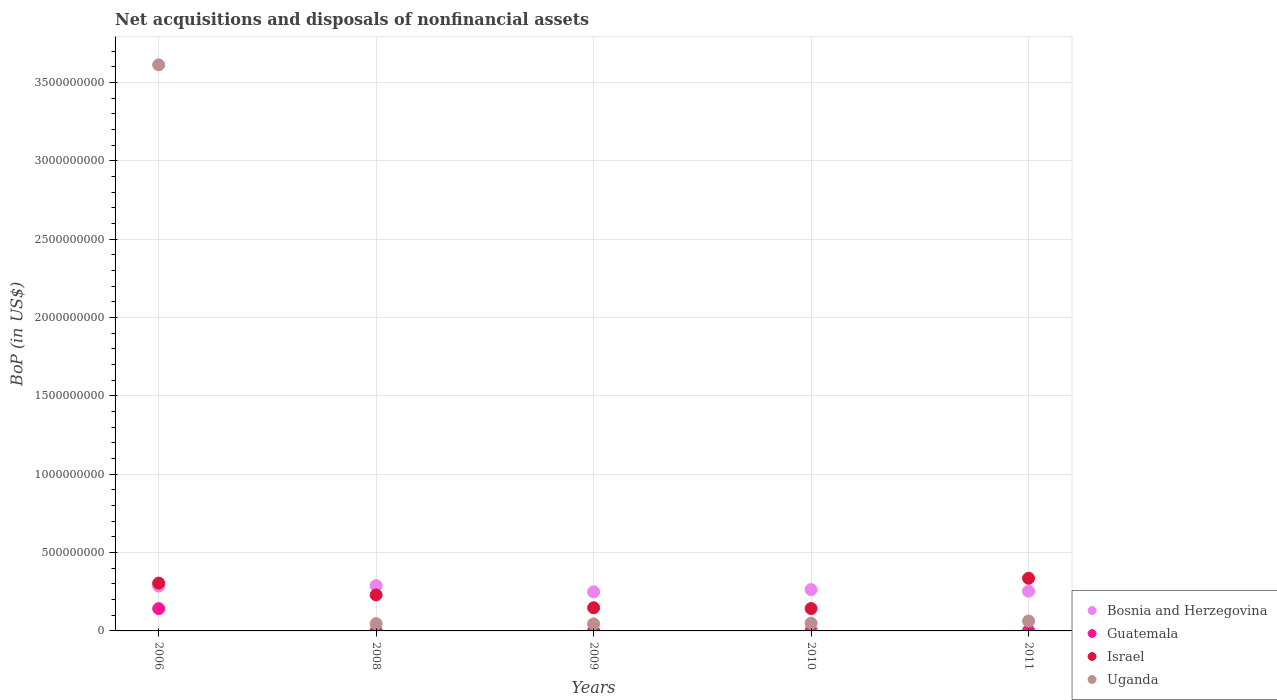How many different coloured dotlines are there?
Keep it short and to the point. 4. What is the Balance of Payments in Uganda in 2009?
Give a very brief answer. 4.49e+07. Across all years, what is the maximum Balance of Payments in Guatemala?
Keep it short and to the point. 1.42e+08. Across all years, what is the minimum Balance of Payments in Uganda?
Provide a short and direct response. 4.49e+07. In which year was the Balance of Payments in Guatemala maximum?
Your answer should be compact. 2006. In which year was the Balance of Payments in Israel minimum?
Your answer should be very brief. 2010. What is the total Balance of Payments in Bosnia and Herzegovina in the graph?
Your response must be concise. 1.34e+09. What is the difference between the Balance of Payments in Israel in 2008 and that in 2009?
Your response must be concise. 8.19e+07. What is the difference between the Balance of Payments in Uganda in 2006 and the Balance of Payments in Guatemala in 2011?
Make the answer very short. 3.61e+09. What is the average Balance of Payments in Uganda per year?
Ensure brevity in your answer.  7.63e+08. In the year 2009, what is the difference between the Balance of Payments in Bosnia and Herzegovina and Balance of Payments in Guatemala?
Your answer should be compact. 2.48e+08. In how many years, is the Balance of Payments in Guatemala greater than 3400000000 US$?
Provide a succinct answer. 0. What is the ratio of the Balance of Payments in Israel in 2006 to that in 2009?
Offer a terse response. 2.07. What is the difference between the highest and the second highest Balance of Payments in Uganda?
Offer a very short reply. 3.55e+09. What is the difference between the highest and the lowest Balance of Payments in Uganda?
Your response must be concise. 3.57e+09. Is it the case that in every year, the sum of the Balance of Payments in Bosnia and Herzegovina and Balance of Payments in Uganda  is greater than the Balance of Payments in Guatemala?
Ensure brevity in your answer.  Yes. Is the Balance of Payments in Uganda strictly greater than the Balance of Payments in Israel over the years?
Give a very brief answer. No. How many years are there in the graph?
Provide a short and direct response. 5. Does the graph contain grids?
Your answer should be compact. Yes. Where does the legend appear in the graph?
Provide a short and direct response. Bottom right. How many legend labels are there?
Provide a succinct answer. 4. How are the legend labels stacked?
Ensure brevity in your answer.  Vertical. What is the title of the graph?
Make the answer very short. Net acquisitions and disposals of nonfinancial assets. What is the label or title of the Y-axis?
Your response must be concise. BoP (in US$). What is the BoP (in US$) of Bosnia and Herzegovina in 2006?
Your answer should be compact. 2.86e+08. What is the BoP (in US$) in Guatemala in 2006?
Give a very brief answer. 1.42e+08. What is the BoP (in US$) in Israel in 2006?
Ensure brevity in your answer.  3.05e+08. What is the BoP (in US$) in Uganda in 2006?
Your response must be concise. 3.61e+09. What is the BoP (in US$) of Bosnia and Herzegovina in 2008?
Keep it short and to the point. 2.89e+08. What is the BoP (in US$) of Guatemala in 2008?
Ensure brevity in your answer.  1.08e+06. What is the BoP (in US$) of Israel in 2008?
Make the answer very short. 2.30e+08. What is the BoP (in US$) of Uganda in 2008?
Give a very brief answer. 4.65e+07. What is the BoP (in US$) of Bosnia and Herzegovina in 2009?
Provide a succinct answer. 2.49e+08. What is the BoP (in US$) of Guatemala in 2009?
Ensure brevity in your answer.  1.01e+06. What is the BoP (in US$) in Israel in 2009?
Ensure brevity in your answer.  1.48e+08. What is the BoP (in US$) in Uganda in 2009?
Provide a succinct answer. 4.49e+07. What is the BoP (in US$) in Bosnia and Herzegovina in 2010?
Make the answer very short. 2.64e+08. What is the BoP (in US$) in Guatemala in 2010?
Offer a terse response. 2.53e+06. What is the BoP (in US$) of Israel in 2010?
Your answer should be compact. 1.43e+08. What is the BoP (in US$) in Uganda in 2010?
Keep it short and to the point. 4.91e+07. What is the BoP (in US$) of Bosnia and Herzegovina in 2011?
Make the answer very short. 2.54e+08. What is the BoP (in US$) of Guatemala in 2011?
Your answer should be very brief. 2.63e+06. What is the BoP (in US$) of Israel in 2011?
Give a very brief answer. 3.36e+08. What is the BoP (in US$) in Uganda in 2011?
Provide a succinct answer. 6.34e+07. Across all years, what is the maximum BoP (in US$) of Bosnia and Herzegovina?
Offer a terse response. 2.89e+08. Across all years, what is the maximum BoP (in US$) in Guatemala?
Provide a short and direct response. 1.42e+08. Across all years, what is the maximum BoP (in US$) in Israel?
Your answer should be compact. 3.36e+08. Across all years, what is the maximum BoP (in US$) of Uganda?
Provide a short and direct response. 3.61e+09. Across all years, what is the minimum BoP (in US$) of Bosnia and Herzegovina?
Your response must be concise. 2.49e+08. Across all years, what is the minimum BoP (in US$) in Guatemala?
Ensure brevity in your answer.  1.01e+06. Across all years, what is the minimum BoP (in US$) in Israel?
Keep it short and to the point. 1.43e+08. Across all years, what is the minimum BoP (in US$) in Uganda?
Your response must be concise. 4.49e+07. What is the total BoP (in US$) in Bosnia and Herzegovina in the graph?
Give a very brief answer. 1.34e+09. What is the total BoP (in US$) in Guatemala in the graph?
Keep it short and to the point. 1.49e+08. What is the total BoP (in US$) in Israel in the graph?
Your answer should be very brief. 1.16e+09. What is the total BoP (in US$) of Uganda in the graph?
Ensure brevity in your answer.  3.82e+09. What is the difference between the BoP (in US$) of Bosnia and Herzegovina in 2006 and that in 2008?
Provide a short and direct response. -2.60e+06. What is the difference between the BoP (in US$) in Guatemala in 2006 and that in 2008?
Your response must be concise. 1.41e+08. What is the difference between the BoP (in US$) of Israel in 2006 and that in 2008?
Give a very brief answer. 7.55e+07. What is the difference between the BoP (in US$) in Uganda in 2006 and that in 2008?
Keep it short and to the point. 3.57e+09. What is the difference between the BoP (in US$) of Bosnia and Herzegovina in 2006 and that in 2009?
Your answer should be very brief. 3.70e+07. What is the difference between the BoP (in US$) in Guatemala in 2006 and that in 2009?
Provide a short and direct response. 1.41e+08. What is the difference between the BoP (in US$) in Israel in 2006 and that in 2009?
Keep it short and to the point. 1.57e+08. What is the difference between the BoP (in US$) of Uganda in 2006 and that in 2009?
Your answer should be compact. 3.57e+09. What is the difference between the BoP (in US$) of Bosnia and Herzegovina in 2006 and that in 2010?
Your answer should be very brief. 2.25e+07. What is the difference between the BoP (in US$) in Guatemala in 2006 and that in 2010?
Keep it short and to the point. 1.40e+08. What is the difference between the BoP (in US$) in Israel in 2006 and that in 2010?
Your answer should be very brief. 1.62e+08. What is the difference between the BoP (in US$) in Uganda in 2006 and that in 2010?
Your response must be concise. 3.56e+09. What is the difference between the BoP (in US$) in Bosnia and Herzegovina in 2006 and that in 2011?
Keep it short and to the point. 3.25e+07. What is the difference between the BoP (in US$) in Guatemala in 2006 and that in 2011?
Your answer should be very brief. 1.40e+08. What is the difference between the BoP (in US$) of Israel in 2006 and that in 2011?
Keep it short and to the point. -3.09e+07. What is the difference between the BoP (in US$) in Uganda in 2006 and that in 2011?
Your answer should be very brief. 3.55e+09. What is the difference between the BoP (in US$) of Bosnia and Herzegovina in 2008 and that in 2009?
Give a very brief answer. 3.96e+07. What is the difference between the BoP (in US$) in Guatemala in 2008 and that in 2009?
Offer a terse response. 6.75e+04. What is the difference between the BoP (in US$) of Israel in 2008 and that in 2009?
Your answer should be compact. 8.19e+07. What is the difference between the BoP (in US$) of Uganda in 2008 and that in 2009?
Offer a terse response. 1.62e+06. What is the difference between the BoP (in US$) of Bosnia and Herzegovina in 2008 and that in 2010?
Provide a succinct answer. 2.51e+07. What is the difference between the BoP (in US$) of Guatemala in 2008 and that in 2010?
Offer a very short reply. -1.45e+06. What is the difference between the BoP (in US$) in Israel in 2008 and that in 2010?
Offer a very short reply. 8.67e+07. What is the difference between the BoP (in US$) of Uganda in 2008 and that in 2010?
Provide a succinct answer. -2.56e+06. What is the difference between the BoP (in US$) in Bosnia and Herzegovina in 2008 and that in 2011?
Your answer should be compact. 3.51e+07. What is the difference between the BoP (in US$) in Guatemala in 2008 and that in 2011?
Your response must be concise. -1.55e+06. What is the difference between the BoP (in US$) of Israel in 2008 and that in 2011?
Your response must be concise. -1.06e+08. What is the difference between the BoP (in US$) in Uganda in 2008 and that in 2011?
Give a very brief answer. -1.69e+07. What is the difference between the BoP (in US$) in Bosnia and Herzegovina in 2009 and that in 2010?
Offer a very short reply. -1.44e+07. What is the difference between the BoP (in US$) in Guatemala in 2009 and that in 2010?
Provide a short and direct response. -1.52e+06. What is the difference between the BoP (in US$) of Israel in 2009 and that in 2010?
Give a very brief answer. 4.80e+06. What is the difference between the BoP (in US$) of Uganda in 2009 and that in 2010?
Give a very brief answer. -4.18e+06. What is the difference between the BoP (in US$) of Bosnia and Herzegovina in 2009 and that in 2011?
Keep it short and to the point. -4.48e+06. What is the difference between the BoP (in US$) of Guatemala in 2009 and that in 2011?
Make the answer very short. -1.62e+06. What is the difference between the BoP (in US$) of Israel in 2009 and that in 2011?
Your response must be concise. -1.88e+08. What is the difference between the BoP (in US$) of Uganda in 2009 and that in 2011?
Ensure brevity in your answer.  -1.85e+07. What is the difference between the BoP (in US$) of Bosnia and Herzegovina in 2010 and that in 2011?
Provide a succinct answer. 9.94e+06. What is the difference between the BoP (in US$) in Guatemala in 2010 and that in 2011?
Offer a terse response. -9.72e+04. What is the difference between the BoP (in US$) of Israel in 2010 and that in 2011?
Provide a succinct answer. -1.93e+08. What is the difference between the BoP (in US$) in Uganda in 2010 and that in 2011?
Your response must be concise. -1.43e+07. What is the difference between the BoP (in US$) in Bosnia and Herzegovina in 2006 and the BoP (in US$) in Guatemala in 2008?
Your answer should be very brief. 2.85e+08. What is the difference between the BoP (in US$) of Bosnia and Herzegovina in 2006 and the BoP (in US$) of Israel in 2008?
Provide a succinct answer. 5.66e+07. What is the difference between the BoP (in US$) in Bosnia and Herzegovina in 2006 and the BoP (in US$) in Uganda in 2008?
Ensure brevity in your answer.  2.40e+08. What is the difference between the BoP (in US$) in Guatemala in 2006 and the BoP (in US$) in Israel in 2008?
Offer a very short reply. -8.74e+07. What is the difference between the BoP (in US$) of Guatemala in 2006 and the BoP (in US$) of Uganda in 2008?
Offer a very short reply. 9.57e+07. What is the difference between the BoP (in US$) of Israel in 2006 and the BoP (in US$) of Uganda in 2008?
Keep it short and to the point. 2.59e+08. What is the difference between the BoP (in US$) in Bosnia and Herzegovina in 2006 and the BoP (in US$) in Guatemala in 2009?
Provide a succinct answer. 2.85e+08. What is the difference between the BoP (in US$) of Bosnia and Herzegovina in 2006 and the BoP (in US$) of Israel in 2009?
Your answer should be very brief. 1.39e+08. What is the difference between the BoP (in US$) in Bosnia and Herzegovina in 2006 and the BoP (in US$) in Uganda in 2009?
Provide a succinct answer. 2.41e+08. What is the difference between the BoP (in US$) of Guatemala in 2006 and the BoP (in US$) of Israel in 2009?
Your answer should be very brief. -5.50e+06. What is the difference between the BoP (in US$) in Guatemala in 2006 and the BoP (in US$) in Uganda in 2009?
Ensure brevity in your answer.  9.73e+07. What is the difference between the BoP (in US$) of Israel in 2006 and the BoP (in US$) of Uganda in 2009?
Offer a very short reply. 2.60e+08. What is the difference between the BoP (in US$) in Bosnia and Herzegovina in 2006 and the BoP (in US$) in Guatemala in 2010?
Provide a succinct answer. 2.84e+08. What is the difference between the BoP (in US$) in Bosnia and Herzegovina in 2006 and the BoP (in US$) in Israel in 2010?
Your answer should be compact. 1.43e+08. What is the difference between the BoP (in US$) of Bosnia and Herzegovina in 2006 and the BoP (in US$) of Uganda in 2010?
Give a very brief answer. 2.37e+08. What is the difference between the BoP (in US$) in Guatemala in 2006 and the BoP (in US$) in Israel in 2010?
Your answer should be very brief. -7.00e+05. What is the difference between the BoP (in US$) of Guatemala in 2006 and the BoP (in US$) of Uganda in 2010?
Ensure brevity in your answer.  9.31e+07. What is the difference between the BoP (in US$) of Israel in 2006 and the BoP (in US$) of Uganda in 2010?
Keep it short and to the point. 2.56e+08. What is the difference between the BoP (in US$) of Bosnia and Herzegovina in 2006 and the BoP (in US$) of Guatemala in 2011?
Provide a short and direct response. 2.84e+08. What is the difference between the BoP (in US$) of Bosnia and Herzegovina in 2006 and the BoP (in US$) of Israel in 2011?
Keep it short and to the point. -4.98e+07. What is the difference between the BoP (in US$) of Bosnia and Herzegovina in 2006 and the BoP (in US$) of Uganda in 2011?
Provide a short and direct response. 2.23e+08. What is the difference between the BoP (in US$) in Guatemala in 2006 and the BoP (in US$) in Israel in 2011?
Offer a terse response. -1.94e+08. What is the difference between the BoP (in US$) in Guatemala in 2006 and the BoP (in US$) in Uganda in 2011?
Provide a short and direct response. 7.88e+07. What is the difference between the BoP (in US$) in Israel in 2006 and the BoP (in US$) in Uganda in 2011?
Provide a short and direct response. 2.42e+08. What is the difference between the BoP (in US$) in Bosnia and Herzegovina in 2008 and the BoP (in US$) in Guatemala in 2009?
Your response must be concise. 2.88e+08. What is the difference between the BoP (in US$) in Bosnia and Herzegovina in 2008 and the BoP (in US$) in Israel in 2009?
Ensure brevity in your answer.  1.41e+08. What is the difference between the BoP (in US$) of Bosnia and Herzegovina in 2008 and the BoP (in US$) of Uganda in 2009?
Keep it short and to the point. 2.44e+08. What is the difference between the BoP (in US$) in Guatemala in 2008 and the BoP (in US$) in Israel in 2009?
Make the answer very short. -1.47e+08. What is the difference between the BoP (in US$) of Guatemala in 2008 and the BoP (in US$) of Uganda in 2009?
Make the answer very short. -4.38e+07. What is the difference between the BoP (in US$) in Israel in 2008 and the BoP (in US$) in Uganda in 2009?
Your answer should be compact. 1.85e+08. What is the difference between the BoP (in US$) in Bosnia and Herzegovina in 2008 and the BoP (in US$) in Guatemala in 2010?
Give a very brief answer. 2.86e+08. What is the difference between the BoP (in US$) in Bosnia and Herzegovina in 2008 and the BoP (in US$) in Israel in 2010?
Your answer should be compact. 1.46e+08. What is the difference between the BoP (in US$) in Bosnia and Herzegovina in 2008 and the BoP (in US$) in Uganda in 2010?
Provide a succinct answer. 2.40e+08. What is the difference between the BoP (in US$) in Guatemala in 2008 and the BoP (in US$) in Israel in 2010?
Your response must be concise. -1.42e+08. What is the difference between the BoP (in US$) in Guatemala in 2008 and the BoP (in US$) in Uganda in 2010?
Provide a succinct answer. -4.80e+07. What is the difference between the BoP (in US$) in Israel in 2008 and the BoP (in US$) in Uganda in 2010?
Keep it short and to the point. 1.81e+08. What is the difference between the BoP (in US$) of Bosnia and Herzegovina in 2008 and the BoP (in US$) of Guatemala in 2011?
Make the answer very short. 2.86e+08. What is the difference between the BoP (in US$) in Bosnia and Herzegovina in 2008 and the BoP (in US$) in Israel in 2011?
Make the answer very short. -4.72e+07. What is the difference between the BoP (in US$) in Bosnia and Herzegovina in 2008 and the BoP (in US$) in Uganda in 2011?
Make the answer very short. 2.25e+08. What is the difference between the BoP (in US$) of Guatemala in 2008 and the BoP (in US$) of Israel in 2011?
Give a very brief answer. -3.35e+08. What is the difference between the BoP (in US$) of Guatemala in 2008 and the BoP (in US$) of Uganda in 2011?
Provide a short and direct response. -6.23e+07. What is the difference between the BoP (in US$) in Israel in 2008 and the BoP (in US$) in Uganda in 2011?
Your answer should be compact. 1.66e+08. What is the difference between the BoP (in US$) in Bosnia and Herzegovina in 2009 and the BoP (in US$) in Guatemala in 2010?
Keep it short and to the point. 2.47e+08. What is the difference between the BoP (in US$) in Bosnia and Herzegovina in 2009 and the BoP (in US$) in Israel in 2010?
Provide a succinct answer. 1.06e+08. What is the difference between the BoP (in US$) of Bosnia and Herzegovina in 2009 and the BoP (in US$) of Uganda in 2010?
Your answer should be compact. 2.00e+08. What is the difference between the BoP (in US$) of Guatemala in 2009 and the BoP (in US$) of Israel in 2010?
Provide a succinct answer. -1.42e+08. What is the difference between the BoP (in US$) in Guatemala in 2009 and the BoP (in US$) in Uganda in 2010?
Give a very brief answer. -4.81e+07. What is the difference between the BoP (in US$) in Israel in 2009 and the BoP (in US$) in Uganda in 2010?
Give a very brief answer. 9.86e+07. What is the difference between the BoP (in US$) of Bosnia and Herzegovina in 2009 and the BoP (in US$) of Guatemala in 2011?
Keep it short and to the point. 2.47e+08. What is the difference between the BoP (in US$) of Bosnia and Herzegovina in 2009 and the BoP (in US$) of Israel in 2011?
Provide a short and direct response. -8.68e+07. What is the difference between the BoP (in US$) in Bosnia and Herzegovina in 2009 and the BoP (in US$) in Uganda in 2011?
Make the answer very short. 1.86e+08. What is the difference between the BoP (in US$) in Guatemala in 2009 and the BoP (in US$) in Israel in 2011?
Offer a very short reply. -3.35e+08. What is the difference between the BoP (in US$) in Guatemala in 2009 and the BoP (in US$) in Uganda in 2011?
Make the answer very short. -6.24e+07. What is the difference between the BoP (in US$) in Israel in 2009 and the BoP (in US$) in Uganda in 2011?
Offer a very short reply. 8.43e+07. What is the difference between the BoP (in US$) of Bosnia and Herzegovina in 2010 and the BoP (in US$) of Guatemala in 2011?
Your answer should be very brief. 2.61e+08. What is the difference between the BoP (in US$) of Bosnia and Herzegovina in 2010 and the BoP (in US$) of Israel in 2011?
Keep it short and to the point. -7.23e+07. What is the difference between the BoP (in US$) in Bosnia and Herzegovina in 2010 and the BoP (in US$) in Uganda in 2011?
Your response must be concise. 2.00e+08. What is the difference between the BoP (in US$) in Guatemala in 2010 and the BoP (in US$) in Israel in 2011?
Your response must be concise. -3.33e+08. What is the difference between the BoP (in US$) of Guatemala in 2010 and the BoP (in US$) of Uganda in 2011?
Your response must be concise. -6.08e+07. What is the difference between the BoP (in US$) of Israel in 2010 and the BoP (in US$) of Uganda in 2011?
Keep it short and to the point. 7.95e+07. What is the average BoP (in US$) of Bosnia and Herzegovina per year?
Your answer should be very brief. 2.68e+08. What is the average BoP (in US$) in Guatemala per year?
Keep it short and to the point. 2.99e+07. What is the average BoP (in US$) in Israel per year?
Offer a terse response. 2.32e+08. What is the average BoP (in US$) in Uganda per year?
Your answer should be very brief. 7.63e+08. In the year 2006, what is the difference between the BoP (in US$) in Bosnia and Herzegovina and BoP (in US$) in Guatemala?
Offer a terse response. 1.44e+08. In the year 2006, what is the difference between the BoP (in US$) in Bosnia and Herzegovina and BoP (in US$) in Israel?
Give a very brief answer. -1.89e+07. In the year 2006, what is the difference between the BoP (in US$) in Bosnia and Herzegovina and BoP (in US$) in Uganda?
Make the answer very short. -3.33e+09. In the year 2006, what is the difference between the BoP (in US$) of Guatemala and BoP (in US$) of Israel?
Your response must be concise. -1.63e+08. In the year 2006, what is the difference between the BoP (in US$) of Guatemala and BoP (in US$) of Uganda?
Provide a short and direct response. -3.47e+09. In the year 2006, what is the difference between the BoP (in US$) in Israel and BoP (in US$) in Uganda?
Ensure brevity in your answer.  -3.31e+09. In the year 2008, what is the difference between the BoP (in US$) of Bosnia and Herzegovina and BoP (in US$) of Guatemala?
Your answer should be compact. 2.88e+08. In the year 2008, what is the difference between the BoP (in US$) in Bosnia and Herzegovina and BoP (in US$) in Israel?
Your answer should be compact. 5.92e+07. In the year 2008, what is the difference between the BoP (in US$) in Bosnia and Herzegovina and BoP (in US$) in Uganda?
Your answer should be compact. 2.42e+08. In the year 2008, what is the difference between the BoP (in US$) in Guatemala and BoP (in US$) in Israel?
Your response must be concise. -2.29e+08. In the year 2008, what is the difference between the BoP (in US$) of Guatemala and BoP (in US$) of Uganda?
Give a very brief answer. -4.54e+07. In the year 2008, what is the difference between the BoP (in US$) of Israel and BoP (in US$) of Uganda?
Keep it short and to the point. 1.83e+08. In the year 2009, what is the difference between the BoP (in US$) of Bosnia and Herzegovina and BoP (in US$) of Guatemala?
Offer a very short reply. 2.48e+08. In the year 2009, what is the difference between the BoP (in US$) of Bosnia and Herzegovina and BoP (in US$) of Israel?
Your response must be concise. 1.02e+08. In the year 2009, what is the difference between the BoP (in US$) in Bosnia and Herzegovina and BoP (in US$) in Uganda?
Your answer should be very brief. 2.04e+08. In the year 2009, what is the difference between the BoP (in US$) of Guatemala and BoP (in US$) of Israel?
Provide a succinct answer. -1.47e+08. In the year 2009, what is the difference between the BoP (in US$) in Guatemala and BoP (in US$) in Uganda?
Your answer should be compact. -4.39e+07. In the year 2009, what is the difference between the BoP (in US$) of Israel and BoP (in US$) of Uganda?
Your answer should be compact. 1.03e+08. In the year 2010, what is the difference between the BoP (in US$) of Bosnia and Herzegovina and BoP (in US$) of Guatemala?
Your answer should be very brief. 2.61e+08. In the year 2010, what is the difference between the BoP (in US$) of Bosnia and Herzegovina and BoP (in US$) of Israel?
Make the answer very short. 1.21e+08. In the year 2010, what is the difference between the BoP (in US$) in Bosnia and Herzegovina and BoP (in US$) in Uganda?
Offer a very short reply. 2.15e+08. In the year 2010, what is the difference between the BoP (in US$) in Guatemala and BoP (in US$) in Israel?
Ensure brevity in your answer.  -1.40e+08. In the year 2010, what is the difference between the BoP (in US$) in Guatemala and BoP (in US$) in Uganda?
Give a very brief answer. -4.65e+07. In the year 2010, what is the difference between the BoP (in US$) of Israel and BoP (in US$) of Uganda?
Provide a short and direct response. 9.38e+07. In the year 2011, what is the difference between the BoP (in US$) of Bosnia and Herzegovina and BoP (in US$) of Guatemala?
Provide a succinct answer. 2.51e+08. In the year 2011, what is the difference between the BoP (in US$) in Bosnia and Herzegovina and BoP (in US$) in Israel?
Make the answer very short. -8.23e+07. In the year 2011, what is the difference between the BoP (in US$) in Bosnia and Herzegovina and BoP (in US$) in Uganda?
Give a very brief answer. 1.90e+08. In the year 2011, what is the difference between the BoP (in US$) of Guatemala and BoP (in US$) of Israel?
Give a very brief answer. -3.33e+08. In the year 2011, what is the difference between the BoP (in US$) of Guatemala and BoP (in US$) of Uganda?
Ensure brevity in your answer.  -6.07e+07. In the year 2011, what is the difference between the BoP (in US$) of Israel and BoP (in US$) of Uganda?
Ensure brevity in your answer.  2.73e+08. What is the ratio of the BoP (in US$) of Guatemala in 2006 to that in 2008?
Your answer should be very brief. 131.74. What is the ratio of the BoP (in US$) in Israel in 2006 to that in 2008?
Your answer should be compact. 1.33. What is the ratio of the BoP (in US$) of Uganda in 2006 to that in 2008?
Your answer should be compact. 77.69. What is the ratio of the BoP (in US$) of Bosnia and Herzegovina in 2006 to that in 2009?
Your answer should be compact. 1.15. What is the ratio of the BoP (in US$) of Guatemala in 2006 to that in 2009?
Keep it short and to the point. 140.53. What is the ratio of the BoP (in US$) of Israel in 2006 to that in 2009?
Ensure brevity in your answer.  2.07. What is the ratio of the BoP (in US$) of Uganda in 2006 to that in 2009?
Provide a succinct answer. 80.5. What is the ratio of the BoP (in US$) of Bosnia and Herzegovina in 2006 to that in 2010?
Give a very brief answer. 1.09. What is the ratio of the BoP (in US$) of Guatemala in 2006 to that in 2010?
Your answer should be compact. 56.14. What is the ratio of the BoP (in US$) in Israel in 2006 to that in 2010?
Your answer should be very brief. 2.14. What is the ratio of the BoP (in US$) in Uganda in 2006 to that in 2010?
Your answer should be very brief. 73.64. What is the ratio of the BoP (in US$) in Bosnia and Herzegovina in 2006 to that in 2011?
Your answer should be very brief. 1.13. What is the ratio of the BoP (in US$) of Guatemala in 2006 to that in 2011?
Offer a terse response. 54.06. What is the ratio of the BoP (in US$) of Israel in 2006 to that in 2011?
Make the answer very short. 0.91. What is the ratio of the BoP (in US$) in Uganda in 2006 to that in 2011?
Your response must be concise. 57.02. What is the ratio of the BoP (in US$) in Bosnia and Herzegovina in 2008 to that in 2009?
Your answer should be very brief. 1.16. What is the ratio of the BoP (in US$) of Guatemala in 2008 to that in 2009?
Ensure brevity in your answer.  1.07. What is the ratio of the BoP (in US$) of Israel in 2008 to that in 2009?
Ensure brevity in your answer.  1.55. What is the ratio of the BoP (in US$) of Uganda in 2008 to that in 2009?
Your answer should be compact. 1.04. What is the ratio of the BoP (in US$) of Bosnia and Herzegovina in 2008 to that in 2010?
Your answer should be very brief. 1.1. What is the ratio of the BoP (in US$) in Guatemala in 2008 to that in 2010?
Offer a terse response. 0.43. What is the ratio of the BoP (in US$) in Israel in 2008 to that in 2010?
Keep it short and to the point. 1.61. What is the ratio of the BoP (in US$) of Uganda in 2008 to that in 2010?
Offer a very short reply. 0.95. What is the ratio of the BoP (in US$) of Bosnia and Herzegovina in 2008 to that in 2011?
Your answer should be compact. 1.14. What is the ratio of the BoP (in US$) of Guatemala in 2008 to that in 2011?
Offer a very short reply. 0.41. What is the ratio of the BoP (in US$) in Israel in 2008 to that in 2011?
Offer a terse response. 0.68. What is the ratio of the BoP (in US$) of Uganda in 2008 to that in 2011?
Give a very brief answer. 0.73. What is the ratio of the BoP (in US$) in Bosnia and Herzegovina in 2009 to that in 2010?
Give a very brief answer. 0.95. What is the ratio of the BoP (in US$) of Guatemala in 2009 to that in 2010?
Ensure brevity in your answer.  0.4. What is the ratio of the BoP (in US$) in Israel in 2009 to that in 2010?
Keep it short and to the point. 1.03. What is the ratio of the BoP (in US$) in Uganda in 2009 to that in 2010?
Give a very brief answer. 0.91. What is the ratio of the BoP (in US$) in Bosnia and Herzegovina in 2009 to that in 2011?
Offer a very short reply. 0.98. What is the ratio of the BoP (in US$) of Guatemala in 2009 to that in 2011?
Provide a succinct answer. 0.38. What is the ratio of the BoP (in US$) of Israel in 2009 to that in 2011?
Give a very brief answer. 0.44. What is the ratio of the BoP (in US$) of Uganda in 2009 to that in 2011?
Offer a very short reply. 0.71. What is the ratio of the BoP (in US$) of Bosnia and Herzegovina in 2010 to that in 2011?
Make the answer very short. 1.04. What is the ratio of the BoP (in US$) in Israel in 2010 to that in 2011?
Keep it short and to the point. 0.43. What is the ratio of the BoP (in US$) of Uganda in 2010 to that in 2011?
Your response must be concise. 0.77. What is the difference between the highest and the second highest BoP (in US$) of Bosnia and Herzegovina?
Your answer should be compact. 2.60e+06. What is the difference between the highest and the second highest BoP (in US$) of Guatemala?
Your answer should be very brief. 1.40e+08. What is the difference between the highest and the second highest BoP (in US$) in Israel?
Keep it short and to the point. 3.09e+07. What is the difference between the highest and the second highest BoP (in US$) in Uganda?
Ensure brevity in your answer.  3.55e+09. What is the difference between the highest and the lowest BoP (in US$) in Bosnia and Herzegovina?
Your response must be concise. 3.96e+07. What is the difference between the highest and the lowest BoP (in US$) in Guatemala?
Provide a short and direct response. 1.41e+08. What is the difference between the highest and the lowest BoP (in US$) of Israel?
Your answer should be compact. 1.93e+08. What is the difference between the highest and the lowest BoP (in US$) of Uganda?
Give a very brief answer. 3.57e+09. 